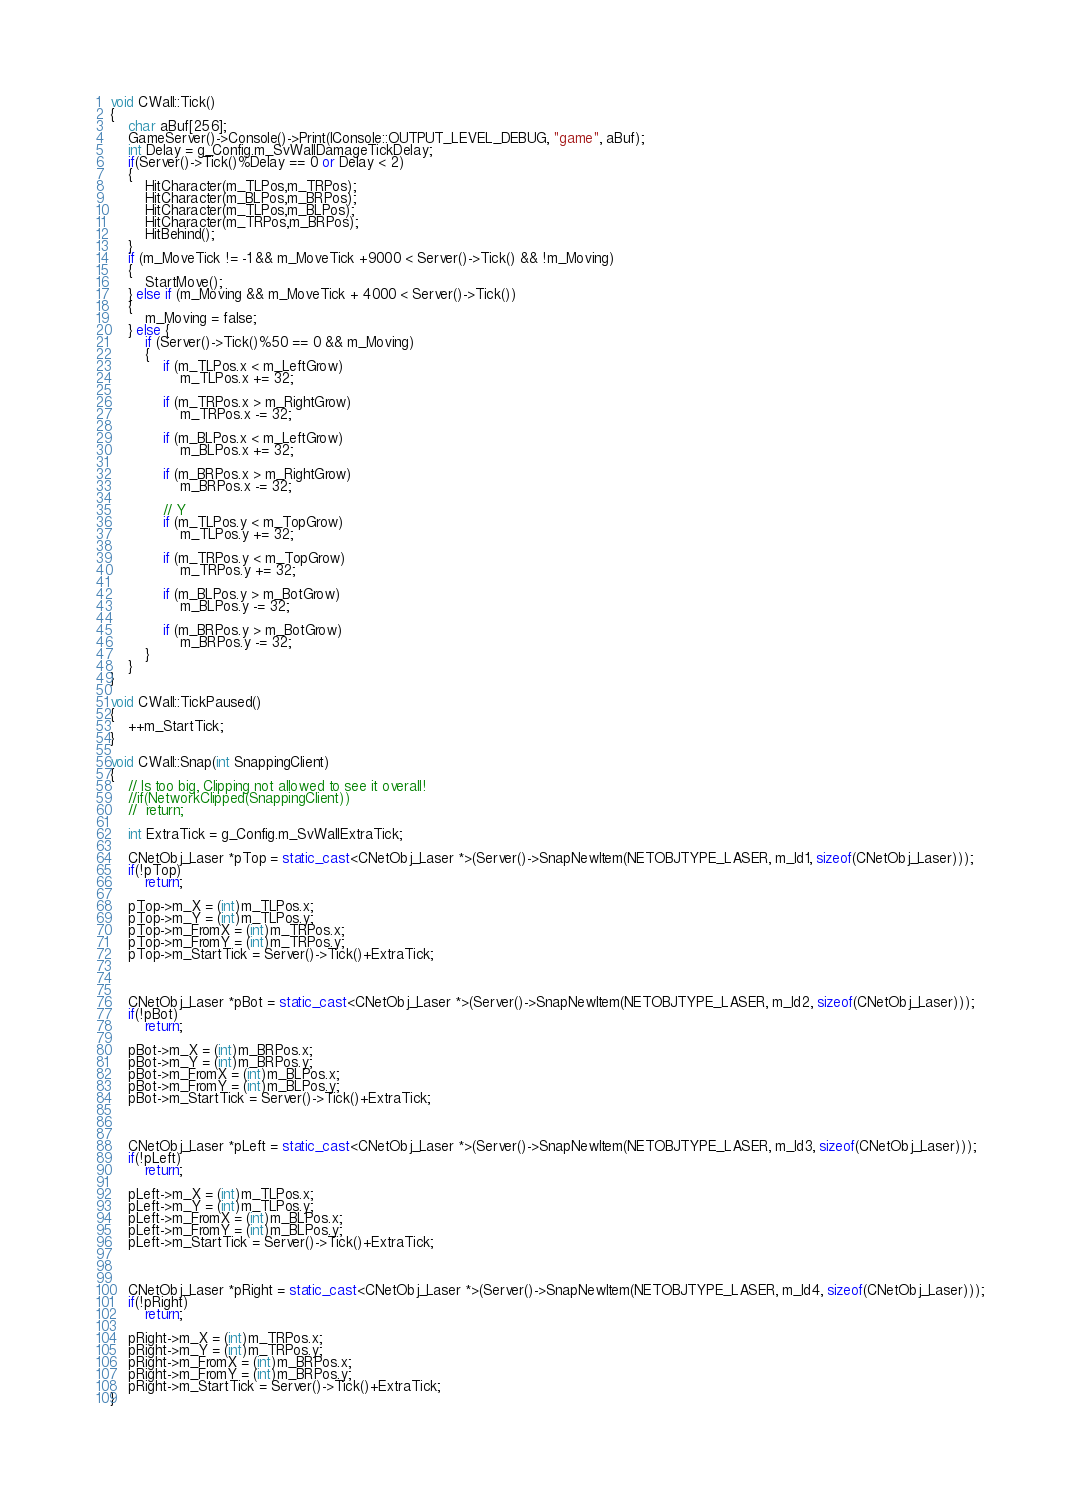Convert code to text. <code><loc_0><loc_0><loc_500><loc_500><_C++_>
void CWall::Tick()
{
	char aBuf[256];
	GameServer()->Console()->Print(IConsole::OUTPUT_LEVEL_DEBUG, "game", aBuf);
	int Delay = g_Config.m_SvWallDamageTickDelay;
	if(Server()->Tick()%Delay == 0 or Delay < 2)
	{
		HitCharacter(m_TLPos,m_TRPos);
		HitCharacter(m_BLPos,m_BRPos);
		HitCharacter(m_TLPos,m_BLPos);
		HitCharacter(m_TRPos,m_BRPos);
		HitBehind();
	}
	if (m_MoveTick != -1 && m_MoveTick +9000 < Server()->Tick() && !m_Moving)
	{
		StartMove();
	} else if (m_Moving && m_MoveTick + 4000 < Server()->Tick())
	{
		m_Moving = false;
	} else {
		if (Server()->Tick()%50 == 0 && m_Moving)
		{
			if (m_TLPos.x < m_LeftGrow)
				m_TLPos.x += 32;

			if (m_TRPos.x > m_RightGrow)
				m_TRPos.x -= 32;

			if (m_BLPos.x < m_LeftGrow)
				m_BLPos.x += 32;

			if (m_BRPos.x > m_RightGrow)
				m_BRPos.x -= 32;

			// Y
			if (m_TLPos.y < m_TopGrow)
				m_TLPos.y += 32;

			if (m_TRPos.y < m_TopGrow)
				m_TRPos.y += 32;

			if (m_BLPos.y > m_BotGrow)
				m_BLPos.y -= 32;

			if (m_BRPos.y > m_BotGrow)
				m_BRPos.y -= 32;
		}
	}
}

void CWall::TickPaused()
{
	++m_StartTick;
}

void CWall::Snap(int SnappingClient)
{
	// Is too big, Clipping not allowed to see it overall!
	//if(NetworkClipped(SnappingClient))
	//	return;

	int ExtraTick = g_Config.m_SvWallExtraTick;

	CNetObj_Laser *pTop = static_cast<CNetObj_Laser *>(Server()->SnapNewItem(NETOBJTYPE_LASER, m_Id1, sizeof(CNetObj_Laser)));
	if(!pTop)
		return;

	pTop->m_X = (int)m_TLPos.x;
	pTop->m_Y = (int)m_TLPos.y;
	pTop->m_FromX = (int)m_TRPos.x;
	pTop->m_FromY = (int)m_TRPos.y;
	pTop->m_StartTick = Server()->Tick()+ExtraTick;
	
	

	CNetObj_Laser *pBot = static_cast<CNetObj_Laser *>(Server()->SnapNewItem(NETOBJTYPE_LASER, m_Id2, sizeof(CNetObj_Laser)));
	if(!pBot)
		return;

	pBot->m_X = (int)m_BRPos.x;
	pBot->m_Y = (int)m_BRPos.y;
	pBot->m_FromX = (int)m_BLPos.x;
	pBot->m_FromY = (int)m_BLPos.y;
	pBot->m_StartTick = Server()->Tick()+ExtraTick;
	
	

	CNetObj_Laser *pLeft = static_cast<CNetObj_Laser *>(Server()->SnapNewItem(NETOBJTYPE_LASER, m_Id3, sizeof(CNetObj_Laser)));
	if(!pLeft)
		return;

	pLeft->m_X = (int)m_TLPos.x;
	pLeft->m_Y = (int)m_TLPos.y;
	pLeft->m_FromX = (int)m_BLPos.x;
	pLeft->m_FromY = (int)m_BLPos.y;
	pLeft->m_StartTick = Server()->Tick()+ExtraTick;
	
	

	CNetObj_Laser *pRight = static_cast<CNetObj_Laser *>(Server()->SnapNewItem(NETOBJTYPE_LASER, m_Id4, sizeof(CNetObj_Laser)));
	if(!pRight)
		return;

	pRight->m_X = (int)m_TRPos.x;
	pRight->m_Y = (int)m_TRPos.y;
	pRight->m_FromX = (int)m_BRPos.x;
	pRight->m_FromY = (int)m_BRPos.y;
	pRight->m_StartTick = Server()->Tick()+ExtraTick;
}
</code> 